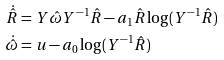Convert formula to latex. <formula><loc_0><loc_0><loc_500><loc_500>\dot { \hat { R } } & = Y \hat { \omega } Y ^ { - 1 } \hat { R } - a _ { 1 } \hat { R } \log ( Y ^ { - 1 } \hat { R } ) \\ \dot { \hat { \omega } } & = u - a _ { 0 } \log ( Y ^ { - 1 } \hat { R } )</formula> 